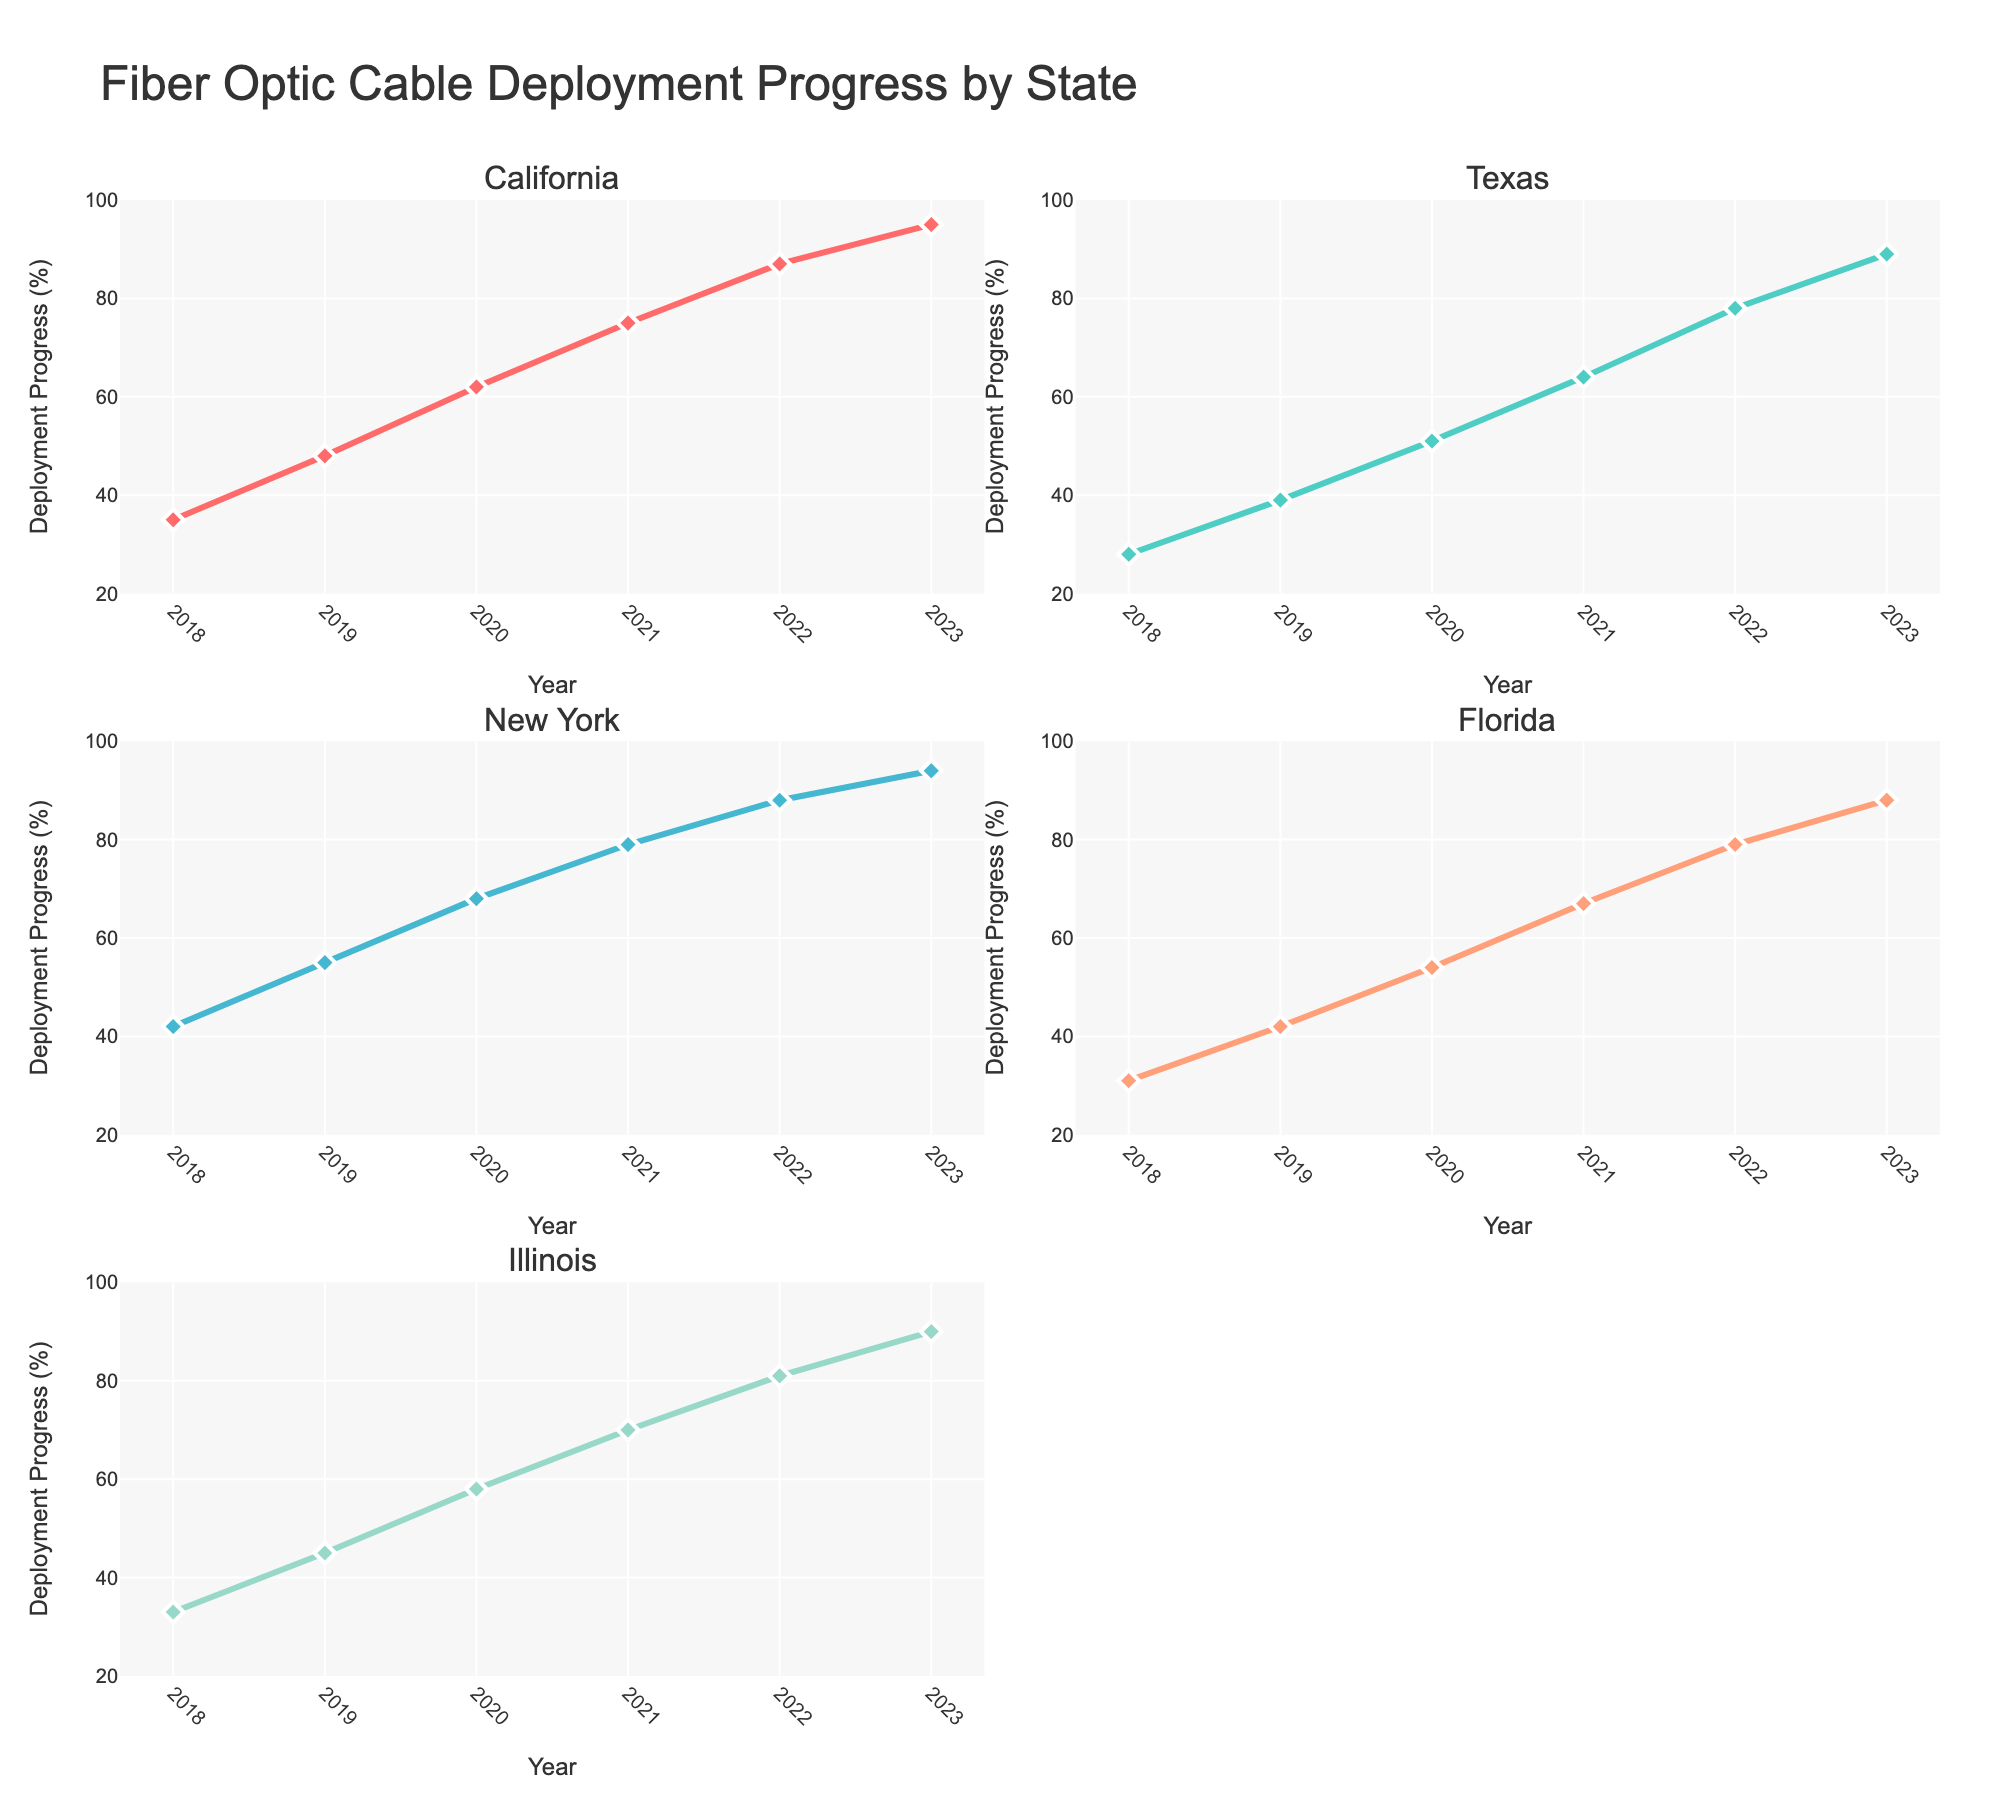Which region has the highest percentage contribution by a single artifact? The percentage contributions for each artifact within their respective regions are observed in the figure. The Persian Rugs from the Middle Eastern region have the highest percentage at 20%.
Answer: Middle Eastern What is the percentage contribution of Japanese Folding Screens? By examining the pie chart for the Asian region, the percentage contribution for Japanese Folding Screens can be identified directly. It shows 18%.
Answer: 18% Calculate the combined percentage of African artifacts displayed in urban lofts. The percentages of African artifacts are Carved Wooden Masks at 10% and Kente Cloth Tapestries at 6%. Adding these together gives 16%.
Answer: 16% Which regions have more than one artifact contributing more than 10 percent each? The figure must be checked for each region's artifacts and their percentages. The European region has Venetian Glass Vases (15%), Antique French Clocks (12%), and the Middle Eastern region has Persian Rugs (20%) and Moroccan Lanterns (11%). Both of these regions meet the criteria.
Answer: European, Middle Eastern Compare the percentage of Carved Wooden Masks to Antique French Clocks. Which is higher and by how much? The percentage for Carved Wooden Masks is 10%, while for Antique French Clocks it is 12%. Subtract 10 from 12 to find the difference. 12% - 10% = 2%.
Answer: Antique French Clocks by 2% What is the artifact with the lowest percentage contribution, and what region is it from? The lowest percentage contribution is 4% from Mexican Talavera Pottery in the South American region.
Answer: Mexican Talavera Pottery, South American Determine the average percentage contribution of Asian artifacts. The Asian artifacts have percentage contributions of 18% (Japanese Folding Screens), 14% (Chinese Porcelain), and 7% (Korean Celadon Pottery). Sum these values: 18% + 14% + 7% = 39%. Then, divide by 3 to get the average: 39% / 3 = 13%.
Answer: 13% Which artifact represents the highest percentage in the European region? In the European region, Venetian Glass Vases hold the highest percentage at 15%.
Answer: Venetian Glass Vases How many artifacts, in total, are represented in the pie charts? Counting all the artifacts listed under each region, we find a total of 12 artifacts.
Answer: 12 Which region has the most diverse range of artifacts, in terms of count? By counting the number of artifacts listed for each region, the European region has the most diverse range with 3 artifacts.
Answer: European 